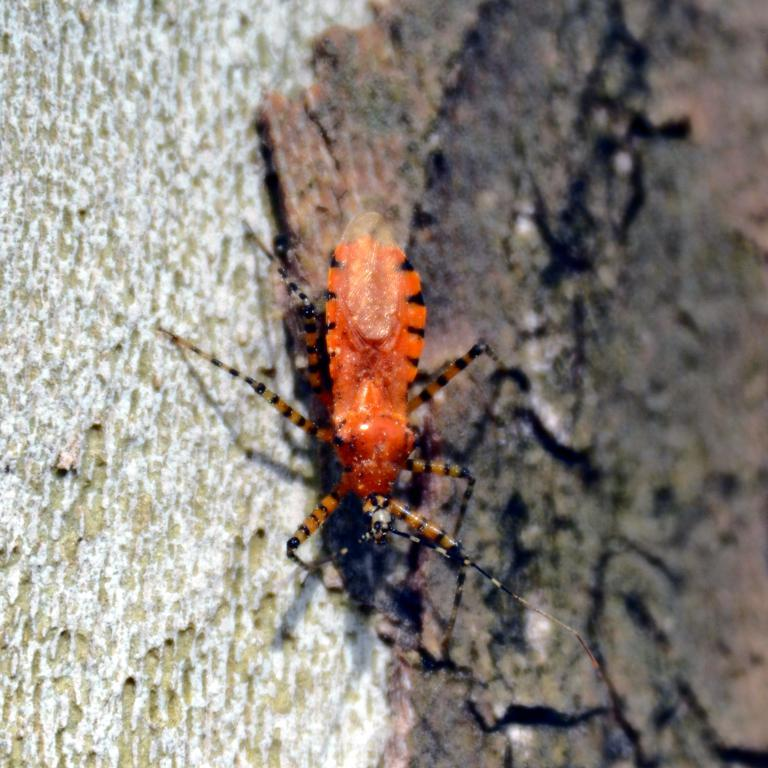What type of creatures can be seen in the image? There are insects in the image. Where are the insects located? The insects are on a wooden surface. What type of thunder can be heard in the image? There is no thunder present in the image, as it is a still image and not an audio recording. 